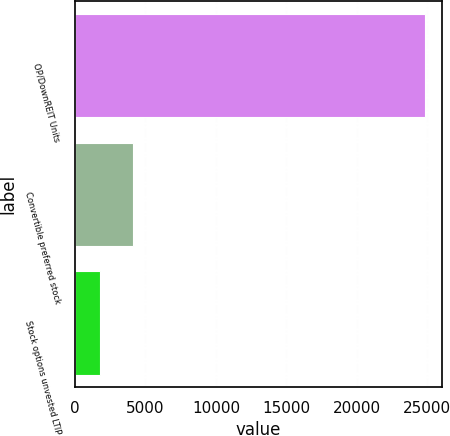Convert chart to OTSL. <chart><loc_0><loc_0><loc_500><loc_500><bar_chart><fcel>OP/DownREIT Units<fcel>Convertible preferred stock<fcel>Stock options unvested LTIP<nl><fcel>24821<fcel>4107.5<fcel>1806<nl></chart> 